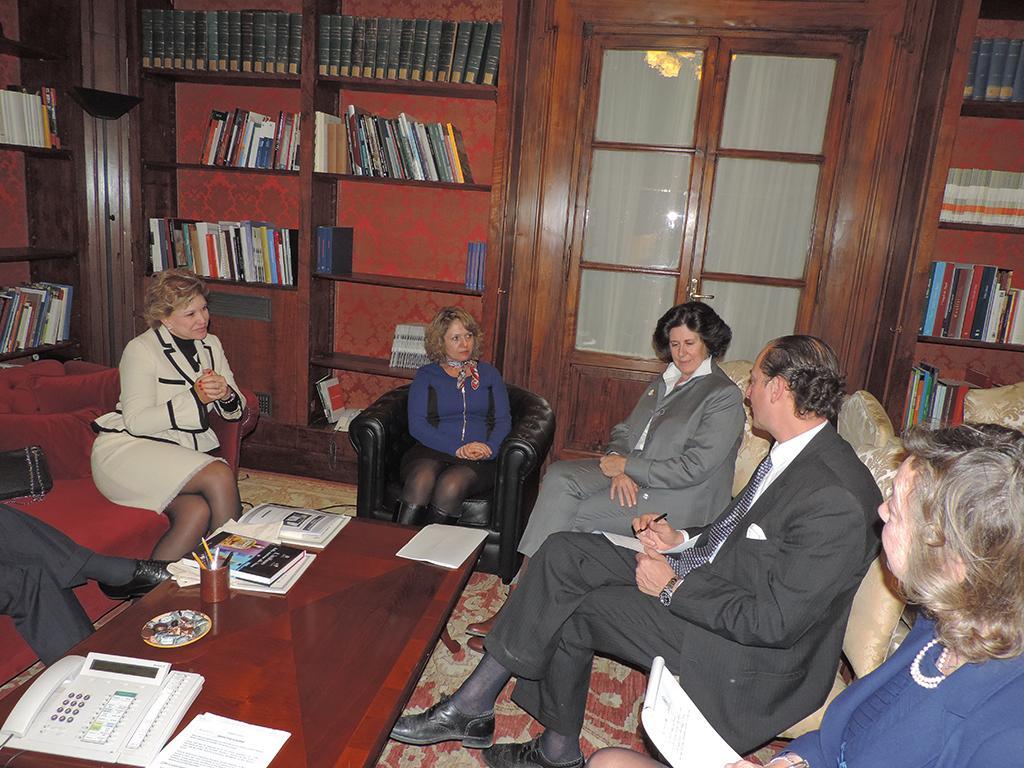How would you summarize this image in a sentence or two? In this image there are people sitting on the chairs. On the left side of the image there are two people sitting on the sofa. In front of them there is a table. On top of it there is a landline phone, books and a few other objects. In the background of the image there is a closed door. There are books on the wooden racks. At the bottom of the image there is a mat on the floor. 